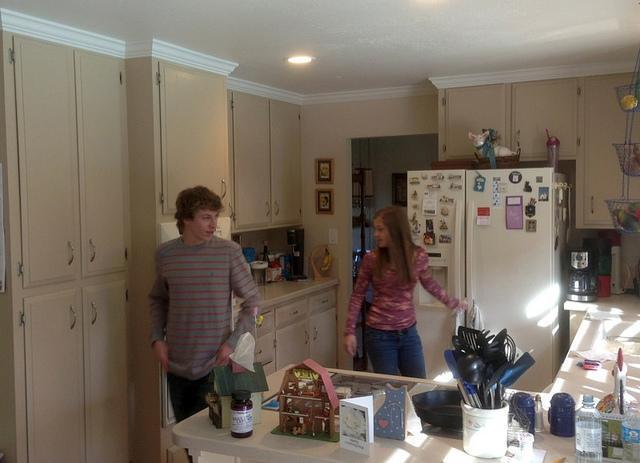How many people live here?
Give a very brief answer. 2. How many men are in the kitchen?
Give a very brief answer. 1. How many people are shown?
Give a very brief answer. 2. How many lights are there?
Give a very brief answer. 1. How many people can you see?
Give a very brief answer. 2. How many refrigerators are there?
Give a very brief answer. 2. How many laptops are on?
Give a very brief answer. 0. 